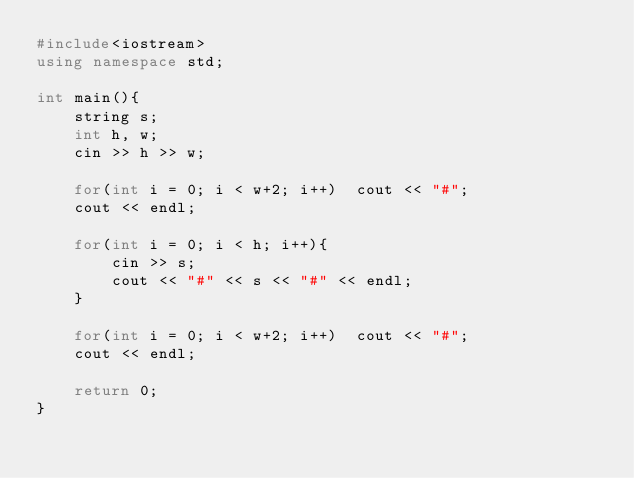Convert code to text. <code><loc_0><loc_0><loc_500><loc_500><_C++_>#include<iostream>
using namespace std;

int main(){
    string s;
    int h, w;
    cin >> h >> w;

    for(int i = 0; i < w+2; i++)  cout << "#";
    cout << endl;

    for(int i = 0; i < h; i++){
        cin >> s;
        cout << "#" << s << "#" << endl;
    }

    for(int i = 0; i < w+2; i++)  cout << "#";
    cout << endl;

    return 0;
}</code> 